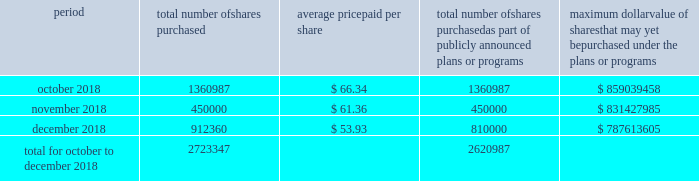Table of content part ii item 5 .
Market for the registrant's common equity , related stockholder matters and issuer purchases of equity securities our common stock is traded on the new york stock exchange under the trading symbol 201chfc . 201d in september 2018 , our board of directors approved a $ 1 billion share repurchase program , which replaced all existing share repurchase programs , authorizing us to repurchase common stock in the open market or through privately negotiated transactions .
The timing and amount of stock repurchases will depend on market conditions and corporate , regulatory and other relevant considerations .
This program may be discontinued at any time by the board of directors .
The table includes repurchases made under this program during the fourth quarter of 2018 .
Period total number of shares purchased average price paid per share total number of shares purchased as part of publicly announced plans or programs maximum dollar value of shares that may yet be purchased under the plans or programs .
During the quarter ended december 31 , 2018 , 102360 shares were withheld from certain executives and employees under the terms of our share-based compensation agreements to provide funds for the payment of payroll and income taxes due at vesting of restricted stock awards .
As of february 13 , 2019 , we had approximately 97419 stockholders , including beneficial owners holding shares in street name .
We intend to consider the declaration of a dividend on a quarterly basis , although there is no assurance as to future dividends since they are dependent upon future earnings , capital requirements , our financial condition and other factors. .
For the quarter ended december 31 , 2018 what was the percent of shares withheld to provide funds for the payment of payroll and income taxes in december? 
Computations: (102360 / 2723347)
Answer: 0.03759. 